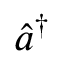<formula> <loc_0><loc_0><loc_500><loc_500>\hat { a } ^ { \dagger }</formula> 